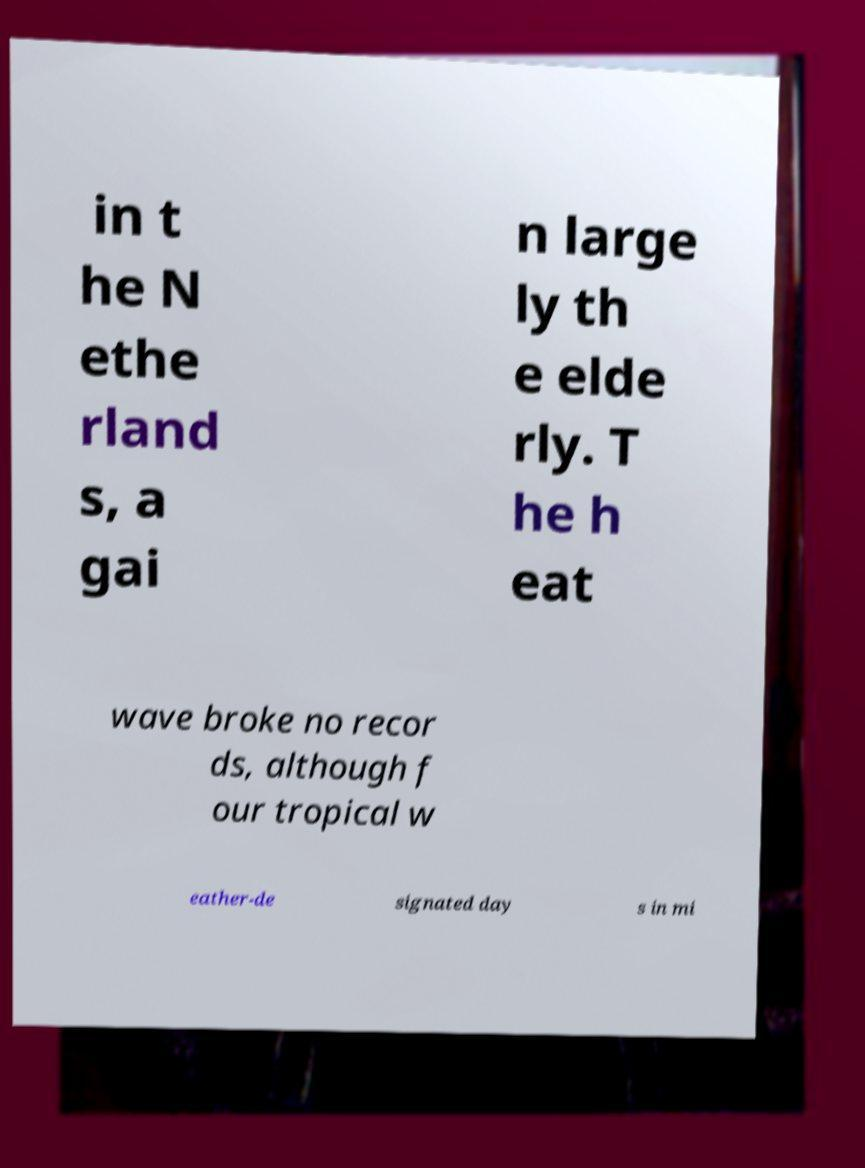Can you read and provide the text displayed in the image?This photo seems to have some interesting text. Can you extract and type it out for me? in t he N ethe rland s, a gai n large ly th e elde rly. T he h eat wave broke no recor ds, although f our tropical w eather-de signated day s in mi 